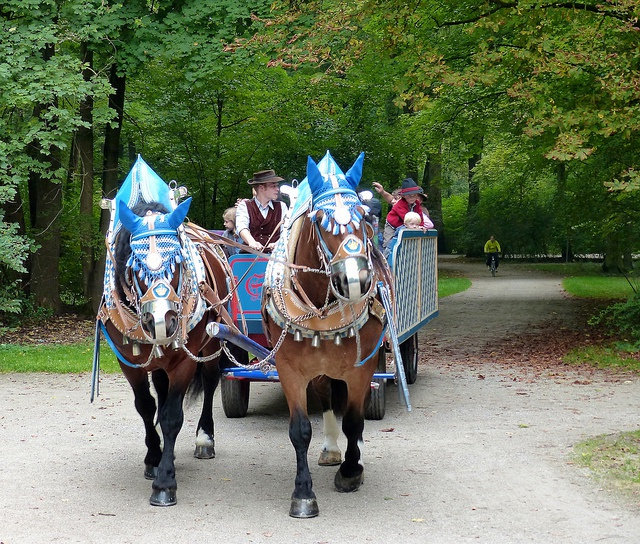Describe the objects in this image and their specific colors. I can see horse in darkgreen, black, white, gray, and darkgray tones, horse in darkgreen, black, maroon, brown, and gray tones, people in darkgreen, white, black, maroon, and gray tones, people in darkgreen, gray, maroon, brown, and darkgray tones, and people in darkgreen, gray, darkgray, and black tones in this image. 